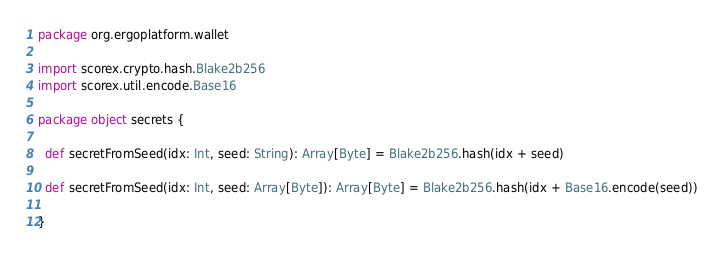<code> <loc_0><loc_0><loc_500><loc_500><_Scala_>package org.ergoplatform.wallet

import scorex.crypto.hash.Blake2b256
import scorex.util.encode.Base16

package object secrets {

  def secretFromSeed(idx: Int, seed: String): Array[Byte] = Blake2b256.hash(idx + seed)

  def secretFromSeed(idx: Int, seed: Array[Byte]): Array[Byte] = Blake2b256.hash(idx + Base16.encode(seed))

}
</code> 